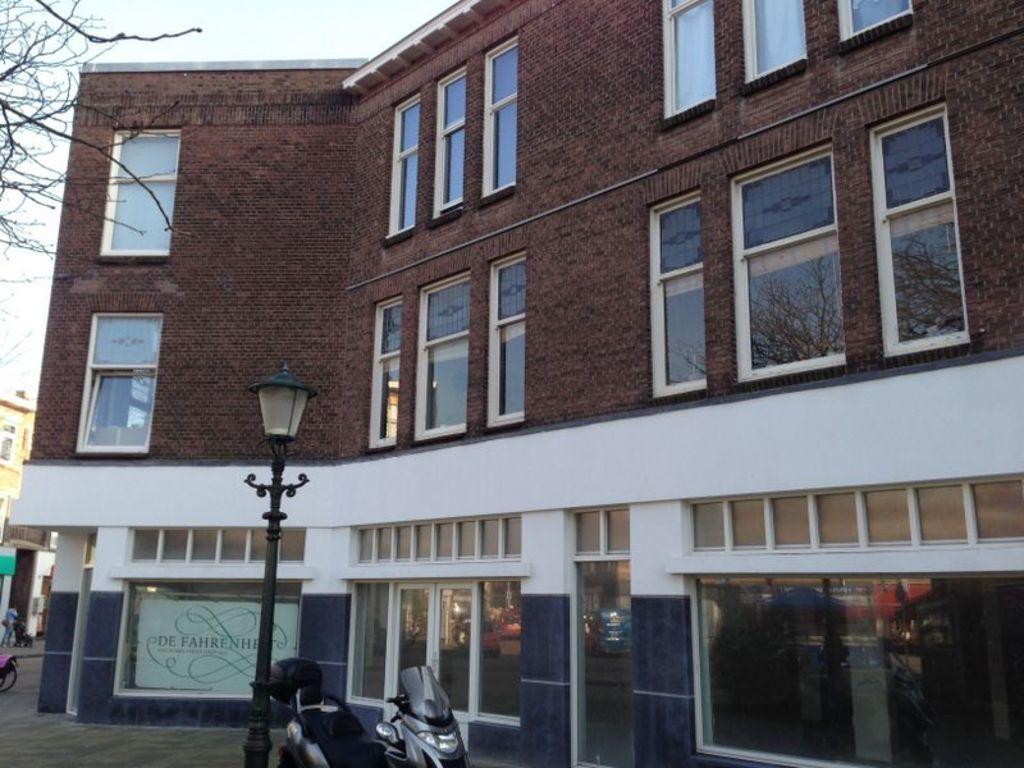Can you describe this image briefly? In this image I can see few buildings, windows, branches of a tree, a pole, a light, a vehicle, a board and on it I can see something is written. 